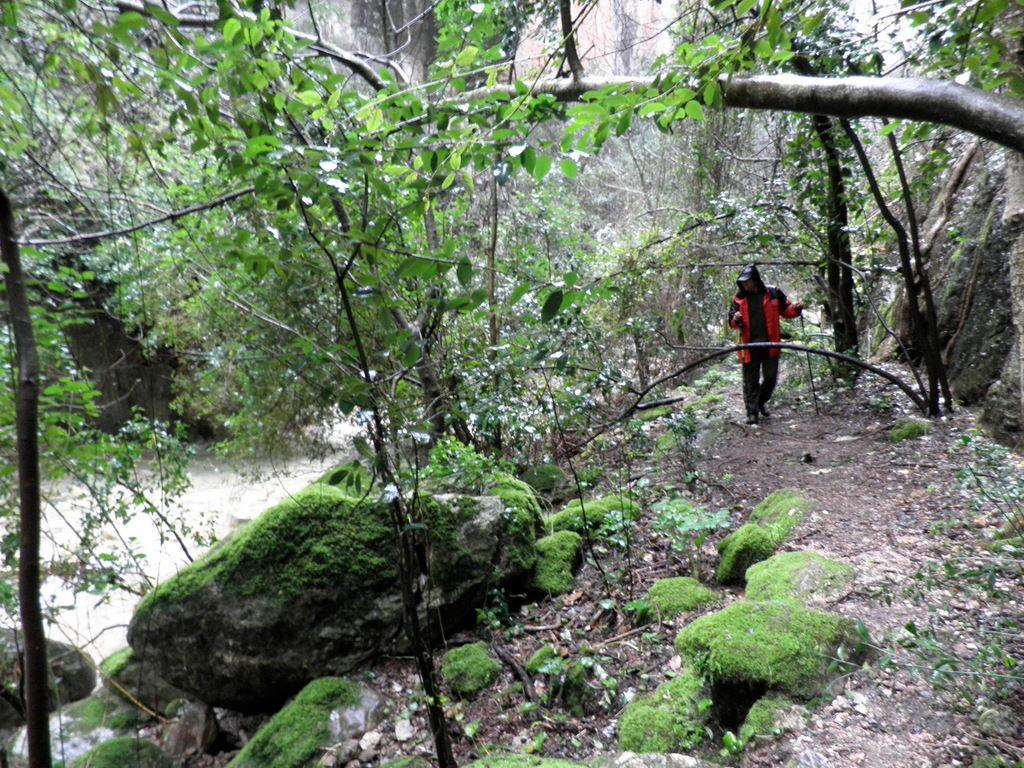Where was the image taken? The image was clicked outside. What can be seen in the middle of the image? There are trees in the middle of the image. What is the person in the image doing? The person is standing in the middle of the image. What is the person wearing? The person is wearing a jacket. What color is the jacket? The jacket is red in color. What type of metal is the representative holding in the image? There is no representative or metal present in the image. What event is taking place in the image? There is no event depicted in the image; it simply shows a person standing near trees outside. 